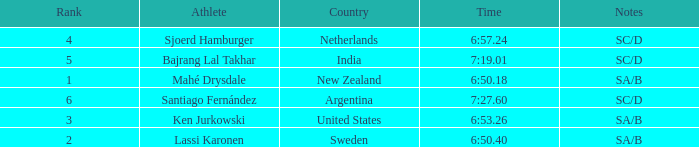What is listed in notes for the athlete, lassi karonen? SA/B. 